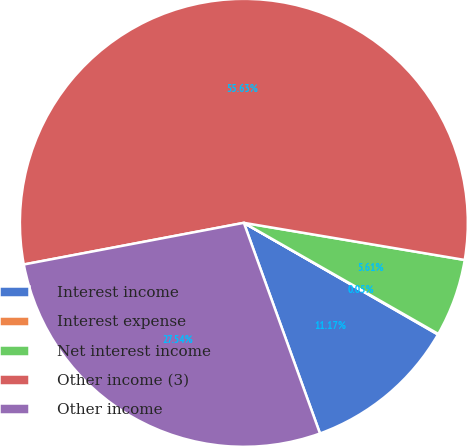Convert chart to OTSL. <chart><loc_0><loc_0><loc_500><loc_500><pie_chart><fcel>Interest income<fcel>Interest expense<fcel>Net interest income<fcel>Other income (3)<fcel>Other income<nl><fcel>11.17%<fcel>0.05%<fcel>5.61%<fcel>55.63%<fcel>27.54%<nl></chart> 